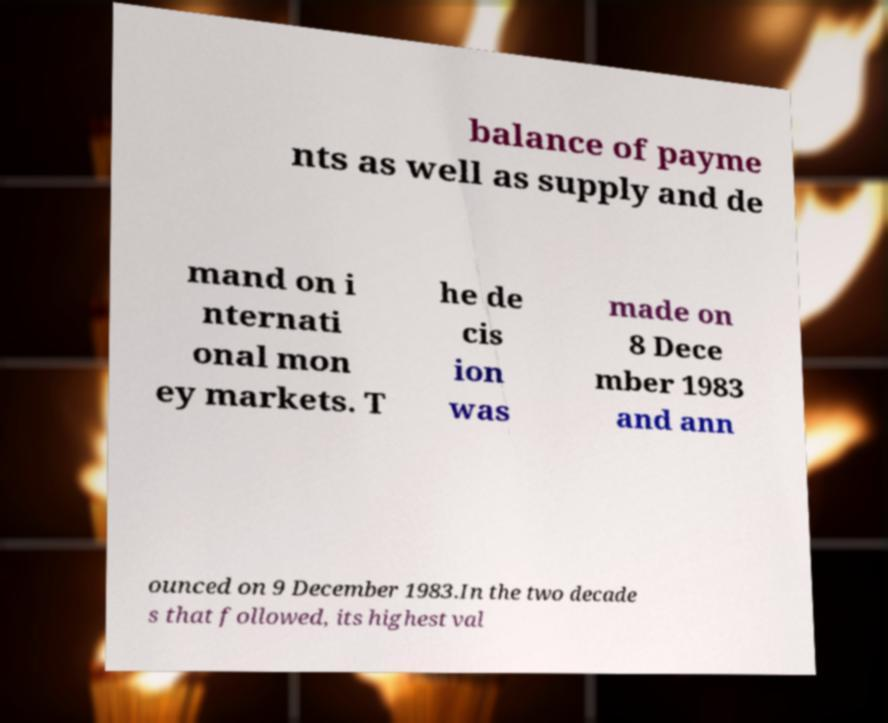Could you extract and type out the text from this image? balance of payme nts as well as supply and de mand on i nternati onal mon ey markets. T he de cis ion was made on 8 Dece mber 1983 and ann ounced on 9 December 1983.In the two decade s that followed, its highest val 